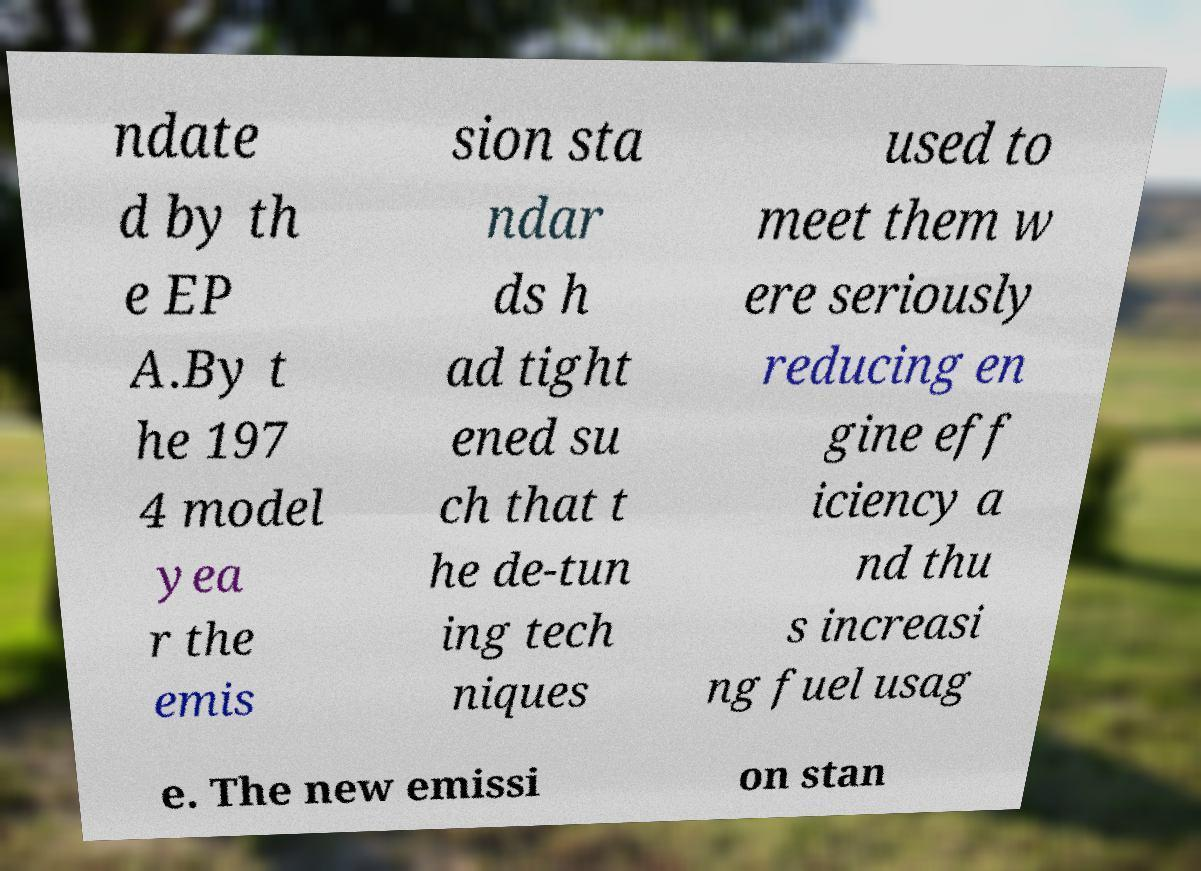I need the written content from this picture converted into text. Can you do that? ndate d by th e EP A.By t he 197 4 model yea r the emis sion sta ndar ds h ad tight ened su ch that t he de-tun ing tech niques used to meet them w ere seriously reducing en gine eff iciency a nd thu s increasi ng fuel usag e. The new emissi on stan 